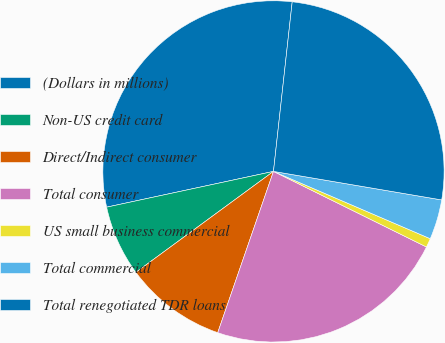Convert chart. <chart><loc_0><loc_0><loc_500><loc_500><pie_chart><fcel>(Dollars in millions)<fcel>Non-US credit card<fcel>Direct/Indirect consumer<fcel>Total consumer<fcel>US small business commercial<fcel>Total commercial<fcel>Total renegotiated TDR loans<nl><fcel>30.11%<fcel>6.71%<fcel>9.63%<fcel>22.99%<fcel>0.85%<fcel>3.78%<fcel>25.92%<nl></chart> 